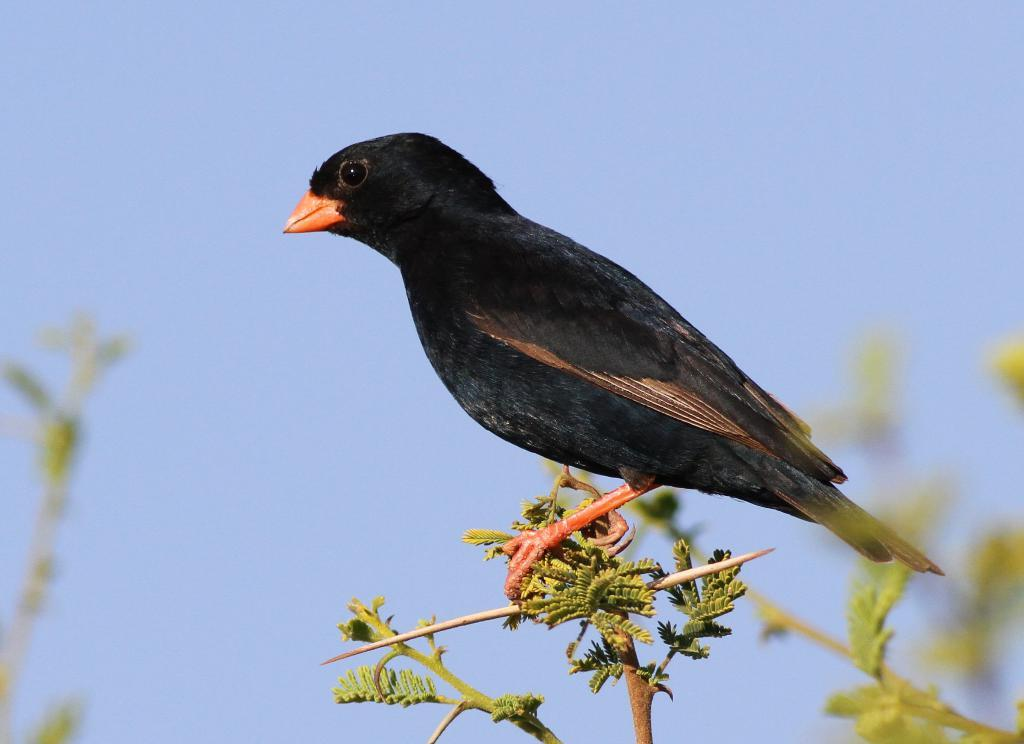What type of animal is in the image? There is a black bird in the image. Where is the bird located in the image? The bird is on a branch of a tree. What can be seen in the background of the image? The sky is visible behind the bird in the image. What type of comb is being used by the bird in the image? There is no comb present in the image, and the bird is not shown using any object. 